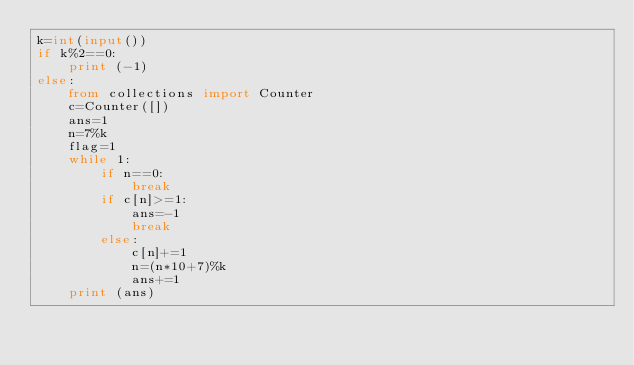<code> <loc_0><loc_0><loc_500><loc_500><_Python_>k=int(input())
if k%2==0:
    print (-1)
else:
    from collections import Counter
    c=Counter([])
    ans=1
    n=7%k
    flag=1
    while 1:
        if n==0:
            break
        if c[n]>=1:
            ans=-1
            break
        else:
            c[n]+=1
            n=(n*10+7)%k
            ans+=1
    print (ans)</code> 